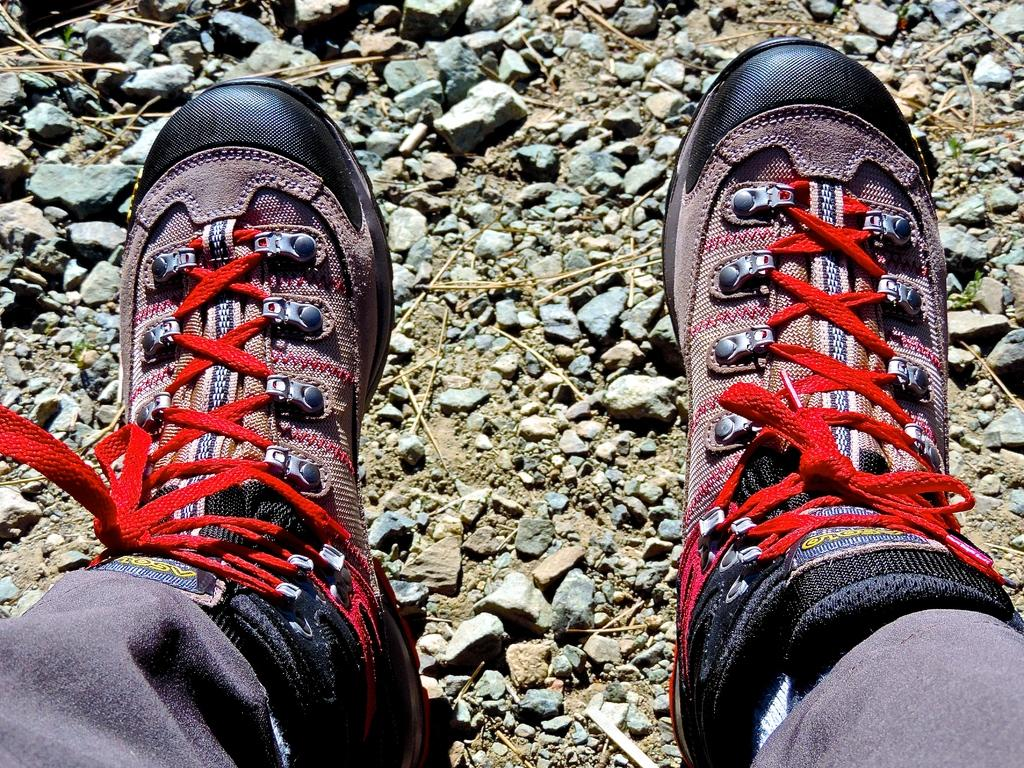What is the person in the image wearing on their feet? The person in the image is wearing shoes. What can be seen on the ground in the image? There are stones on the ground in the image. What type of crime is being committed in the image? There is no crime being committed in the image; it only shows a person wearing shoes and stones on the ground. What teeth can be seen in the image? There are no teeth visible in the image. 